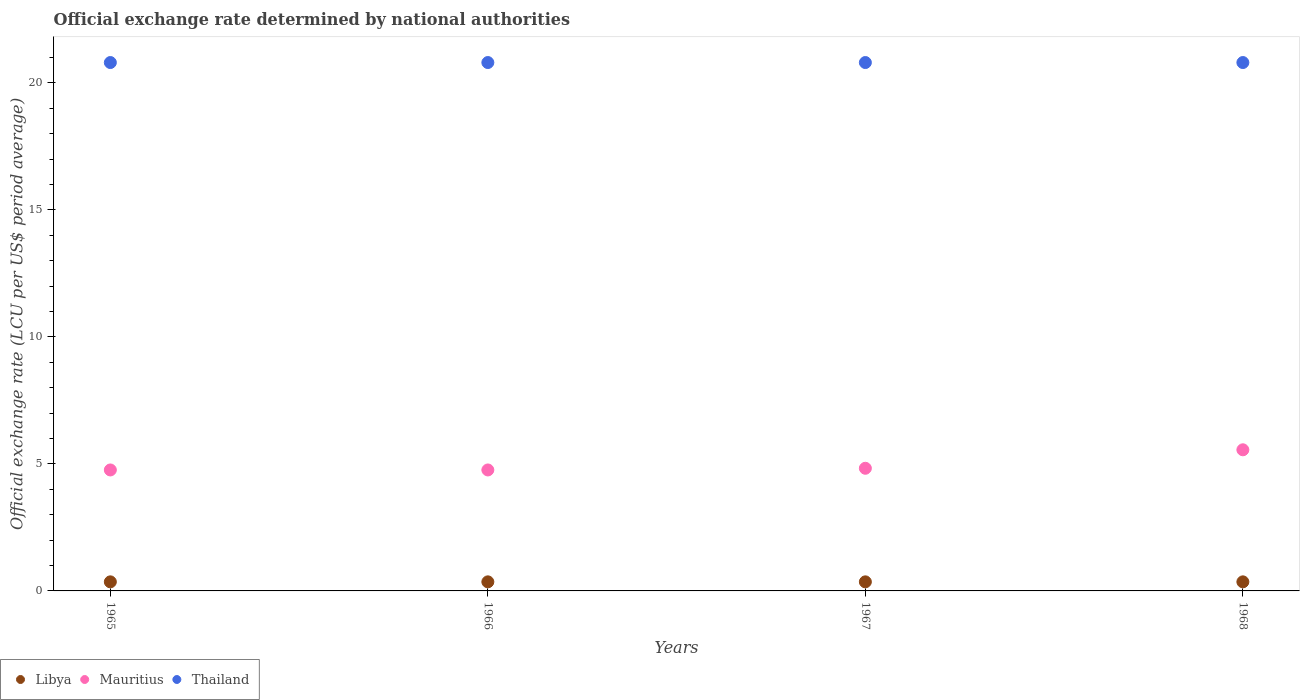Is the number of dotlines equal to the number of legend labels?
Your answer should be compact. Yes. What is the official exchange rate in Thailand in 1967?
Make the answer very short. 20.8. Across all years, what is the maximum official exchange rate in Mauritius?
Ensure brevity in your answer.  5.56. Across all years, what is the minimum official exchange rate in Libya?
Your answer should be very brief. 0.36. In which year was the official exchange rate in Libya maximum?
Offer a terse response. 1965. In which year was the official exchange rate in Mauritius minimum?
Your response must be concise. 1965. What is the total official exchange rate in Thailand in the graph?
Provide a short and direct response. 83.2. What is the difference between the official exchange rate in Mauritius in 1967 and that in 1968?
Offer a very short reply. -0.73. What is the difference between the official exchange rate in Mauritius in 1967 and the official exchange rate in Libya in 1965?
Your answer should be compact. 4.47. What is the average official exchange rate in Thailand per year?
Ensure brevity in your answer.  20.8. In the year 1966, what is the difference between the official exchange rate in Libya and official exchange rate in Thailand?
Your response must be concise. -20.44. In how many years, is the official exchange rate in Thailand greater than 13 LCU?
Your answer should be very brief. 4. What is the ratio of the official exchange rate in Libya in 1965 to that in 1967?
Provide a succinct answer. 1. Is the official exchange rate in Libya in 1965 less than that in 1968?
Make the answer very short. No. Is the difference between the official exchange rate in Libya in 1966 and 1967 greater than the difference between the official exchange rate in Thailand in 1966 and 1967?
Your response must be concise. No. What is the difference between the highest and the second highest official exchange rate in Libya?
Offer a very short reply. 0. What is the difference between the highest and the lowest official exchange rate in Libya?
Make the answer very short. 0. In how many years, is the official exchange rate in Mauritius greater than the average official exchange rate in Mauritius taken over all years?
Make the answer very short. 1. Is it the case that in every year, the sum of the official exchange rate in Mauritius and official exchange rate in Thailand  is greater than the official exchange rate in Libya?
Ensure brevity in your answer.  Yes. Does the official exchange rate in Thailand monotonically increase over the years?
Offer a very short reply. No. Is the official exchange rate in Thailand strictly greater than the official exchange rate in Mauritius over the years?
Your answer should be compact. Yes. How many dotlines are there?
Your answer should be compact. 3. How many years are there in the graph?
Provide a short and direct response. 4. Are the values on the major ticks of Y-axis written in scientific E-notation?
Your answer should be compact. No. Does the graph contain grids?
Provide a succinct answer. No. How many legend labels are there?
Your answer should be compact. 3. How are the legend labels stacked?
Your answer should be very brief. Horizontal. What is the title of the graph?
Make the answer very short. Official exchange rate determined by national authorities. What is the label or title of the Y-axis?
Your answer should be very brief. Official exchange rate (LCU per US$ period average). What is the Official exchange rate (LCU per US$ period average) of Libya in 1965?
Offer a very short reply. 0.36. What is the Official exchange rate (LCU per US$ period average) of Mauritius in 1965?
Provide a succinct answer. 4.76. What is the Official exchange rate (LCU per US$ period average) in Thailand in 1965?
Provide a succinct answer. 20.8. What is the Official exchange rate (LCU per US$ period average) of Libya in 1966?
Make the answer very short. 0.36. What is the Official exchange rate (LCU per US$ period average) of Mauritius in 1966?
Ensure brevity in your answer.  4.76. What is the Official exchange rate (LCU per US$ period average) in Thailand in 1966?
Provide a short and direct response. 20.8. What is the Official exchange rate (LCU per US$ period average) in Libya in 1967?
Provide a succinct answer. 0.36. What is the Official exchange rate (LCU per US$ period average) of Mauritius in 1967?
Provide a short and direct response. 4.83. What is the Official exchange rate (LCU per US$ period average) of Thailand in 1967?
Keep it short and to the point. 20.8. What is the Official exchange rate (LCU per US$ period average) in Libya in 1968?
Provide a short and direct response. 0.36. What is the Official exchange rate (LCU per US$ period average) of Mauritius in 1968?
Provide a succinct answer. 5.56. What is the Official exchange rate (LCU per US$ period average) of Thailand in 1968?
Your response must be concise. 20.8. Across all years, what is the maximum Official exchange rate (LCU per US$ period average) of Libya?
Your answer should be compact. 0.36. Across all years, what is the maximum Official exchange rate (LCU per US$ period average) of Mauritius?
Your answer should be very brief. 5.56. Across all years, what is the maximum Official exchange rate (LCU per US$ period average) of Thailand?
Your answer should be compact. 20.8. Across all years, what is the minimum Official exchange rate (LCU per US$ period average) of Libya?
Provide a short and direct response. 0.36. Across all years, what is the minimum Official exchange rate (LCU per US$ period average) in Mauritius?
Provide a succinct answer. 4.76. Across all years, what is the minimum Official exchange rate (LCU per US$ period average) in Thailand?
Give a very brief answer. 20.8. What is the total Official exchange rate (LCU per US$ period average) in Libya in the graph?
Offer a terse response. 1.43. What is the total Official exchange rate (LCU per US$ period average) of Mauritius in the graph?
Provide a succinct answer. 19.91. What is the total Official exchange rate (LCU per US$ period average) of Thailand in the graph?
Keep it short and to the point. 83.2. What is the difference between the Official exchange rate (LCU per US$ period average) in Libya in 1965 and that in 1966?
Give a very brief answer. 0. What is the difference between the Official exchange rate (LCU per US$ period average) of Libya in 1965 and that in 1967?
Provide a succinct answer. 0. What is the difference between the Official exchange rate (LCU per US$ period average) of Mauritius in 1965 and that in 1967?
Your answer should be compact. -0.07. What is the difference between the Official exchange rate (LCU per US$ period average) in Thailand in 1965 and that in 1967?
Ensure brevity in your answer.  0. What is the difference between the Official exchange rate (LCU per US$ period average) of Mauritius in 1965 and that in 1968?
Ensure brevity in your answer.  -0.79. What is the difference between the Official exchange rate (LCU per US$ period average) in Thailand in 1965 and that in 1968?
Offer a very short reply. 0. What is the difference between the Official exchange rate (LCU per US$ period average) in Libya in 1966 and that in 1967?
Your answer should be compact. 0. What is the difference between the Official exchange rate (LCU per US$ period average) in Mauritius in 1966 and that in 1967?
Provide a short and direct response. -0.07. What is the difference between the Official exchange rate (LCU per US$ period average) of Libya in 1966 and that in 1968?
Your answer should be compact. 0. What is the difference between the Official exchange rate (LCU per US$ period average) of Mauritius in 1966 and that in 1968?
Ensure brevity in your answer.  -0.79. What is the difference between the Official exchange rate (LCU per US$ period average) of Libya in 1967 and that in 1968?
Your answer should be compact. 0. What is the difference between the Official exchange rate (LCU per US$ period average) in Mauritius in 1967 and that in 1968?
Provide a succinct answer. -0.73. What is the difference between the Official exchange rate (LCU per US$ period average) of Thailand in 1967 and that in 1968?
Your response must be concise. 0. What is the difference between the Official exchange rate (LCU per US$ period average) of Libya in 1965 and the Official exchange rate (LCU per US$ period average) of Mauritius in 1966?
Your response must be concise. -4.4. What is the difference between the Official exchange rate (LCU per US$ period average) in Libya in 1965 and the Official exchange rate (LCU per US$ period average) in Thailand in 1966?
Offer a very short reply. -20.44. What is the difference between the Official exchange rate (LCU per US$ period average) of Mauritius in 1965 and the Official exchange rate (LCU per US$ period average) of Thailand in 1966?
Give a very brief answer. -16.04. What is the difference between the Official exchange rate (LCU per US$ period average) in Libya in 1965 and the Official exchange rate (LCU per US$ period average) in Mauritius in 1967?
Your answer should be compact. -4.47. What is the difference between the Official exchange rate (LCU per US$ period average) in Libya in 1965 and the Official exchange rate (LCU per US$ period average) in Thailand in 1967?
Make the answer very short. -20.44. What is the difference between the Official exchange rate (LCU per US$ period average) in Mauritius in 1965 and the Official exchange rate (LCU per US$ period average) in Thailand in 1967?
Offer a terse response. -16.04. What is the difference between the Official exchange rate (LCU per US$ period average) in Libya in 1965 and the Official exchange rate (LCU per US$ period average) in Mauritius in 1968?
Provide a succinct answer. -5.2. What is the difference between the Official exchange rate (LCU per US$ period average) in Libya in 1965 and the Official exchange rate (LCU per US$ period average) in Thailand in 1968?
Offer a very short reply. -20.44. What is the difference between the Official exchange rate (LCU per US$ period average) of Mauritius in 1965 and the Official exchange rate (LCU per US$ period average) of Thailand in 1968?
Give a very brief answer. -16.04. What is the difference between the Official exchange rate (LCU per US$ period average) of Libya in 1966 and the Official exchange rate (LCU per US$ period average) of Mauritius in 1967?
Offer a very short reply. -4.47. What is the difference between the Official exchange rate (LCU per US$ period average) of Libya in 1966 and the Official exchange rate (LCU per US$ period average) of Thailand in 1967?
Offer a very short reply. -20.44. What is the difference between the Official exchange rate (LCU per US$ period average) in Mauritius in 1966 and the Official exchange rate (LCU per US$ period average) in Thailand in 1967?
Offer a terse response. -16.04. What is the difference between the Official exchange rate (LCU per US$ period average) in Libya in 1966 and the Official exchange rate (LCU per US$ period average) in Mauritius in 1968?
Offer a very short reply. -5.2. What is the difference between the Official exchange rate (LCU per US$ period average) in Libya in 1966 and the Official exchange rate (LCU per US$ period average) in Thailand in 1968?
Give a very brief answer. -20.44. What is the difference between the Official exchange rate (LCU per US$ period average) in Mauritius in 1966 and the Official exchange rate (LCU per US$ period average) in Thailand in 1968?
Give a very brief answer. -16.04. What is the difference between the Official exchange rate (LCU per US$ period average) in Libya in 1967 and the Official exchange rate (LCU per US$ period average) in Mauritius in 1968?
Make the answer very short. -5.2. What is the difference between the Official exchange rate (LCU per US$ period average) of Libya in 1967 and the Official exchange rate (LCU per US$ period average) of Thailand in 1968?
Make the answer very short. -20.44. What is the difference between the Official exchange rate (LCU per US$ period average) in Mauritius in 1967 and the Official exchange rate (LCU per US$ period average) in Thailand in 1968?
Provide a short and direct response. -15.97. What is the average Official exchange rate (LCU per US$ period average) of Libya per year?
Your answer should be compact. 0.36. What is the average Official exchange rate (LCU per US$ period average) in Mauritius per year?
Offer a terse response. 4.98. What is the average Official exchange rate (LCU per US$ period average) of Thailand per year?
Ensure brevity in your answer.  20.8. In the year 1965, what is the difference between the Official exchange rate (LCU per US$ period average) in Libya and Official exchange rate (LCU per US$ period average) in Mauritius?
Make the answer very short. -4.4. In the year 1965, what is the difference between the Official exchange rate (LCU per US$ period average) of Libya and Official exchange rate (LCU per US$ period average) of Thailand?
Keep it short and to the point. -20.44. In the year 1965, what is the difference between the Official exchange rate (LCU per US$ period average) of Mauritius and Official exchange rate (LCU per US$ period average) of Thailand?
Make the answer very short. -16.04. In the year 1966, what is the difference between the Official exchange rate (LCU per US$ period average) in Libya and Official exchange rate (LCU per US$ period average) in Mauritius?
Your answer should be compact. -4.4. In the year 1966, what is the difference between the Official exchange rate (LCU per US$ period average) of Libya and Official exchange rate (LCU per US$ period average) of Thailand?
Ensure brevity in your answer.  -20.44. In the year 1966, what is the difference between the Official exchange rate (LCU per US$ period average) of Mauritius and Official exchange rate (LCU per US$ period average) of Thailand?
Your response must be concise. -16.04. In the year 1967, what is the difference between the Official exchange rate (LCU per US$ period average) of Libya and Official exchange rate (LCU per US$ period average) of Mauritius?
Make the answer very short. -4.47. In the year 1967, what is the difference between the Official exchange rate (LCU per US$ period average) in Libya and Official exchange rate (LCU per US$ period average) in Thailand?
Offer a terse response. -20.44. In the year 1967, what is the difference between the Official exchange rate (LCU per US$ period average) in Mauritius and Official exchange rate (LCU per US$ period average) in Thailand?
Your answer should be compact. -15.97. In the year 1968, what is the difference between the Official exchange rate (LCU per US$ period average) in Libya and Official exchange rate (LCU per US$ period average) in Mauritius?
Ensure brevity in your answer.  -5.2. In the year 1968, what is the difference between the Official exchange rate (LCU per US$ period average) of Libya and Official exchange rate (LCU per US$ period average) of Thailand?
Give a very brief answer. -20.44. In the year 1968, what is the difference between the Official exchange rate (LCU per US$ period average) of Mauritius and Official exchange rate (LCU per US$ period average) of Thailand?
Make the answer very short. -15.24. What is the ratio of the Official exchange rate (LCU per US$ period average) of Libya in 1965 to that in 1966?
Your response must be concise. 1. What is the ratio of the Official exchange rate (LCU per US$ period average) in Libya in 1965 to that in 1967?
Offer a terse response. 1. What is the ratio of the Official exchange rate (LCU per US$ period average) of Mauritius in 1965 to that in 1967?
Your answer should be compact. 0.99. What is the ratio of the Official exchange rate (LCU per US$ period average) in Libya in 1965 to that in 1968?
Ensure brevity in your answer.  1. What is the ratio of the Official exchange rate (LCU per US$ period average) in Mauritius in 1965 to that in 1968?
Your answer should be very brief. 0.86. What is the ratio of the Official exchange rate (LCU per US$ period average) in Thailand in 1965 to that in 1968?
Offer a very short reply. 1. What is the ratio of the Official exchange rate (LCU per US$ period average) in Libya in 1966 to that in 1967?
Make the answer very short. 1. What is the ratio of the Official exchange rate (LCU per US$ period average) in Mauritius in 1966 to that in 1967?
Give a very brief answer. 0.99. What is the ratio of the Official exchange rate (LCU per US$ period average) in Thailand in 1966 to that in 1967?
Your answer should be very brief. 1. What is the ratio of the Official exchange rate (LCU per US$ period average) in Libya in 1966 to that in 1968?
Provide a short and direct response. 1. What is the ratio of the Official exchange rate (LCU per US$ period average) in Mauritius in 1966 to that in 1968?
Provide a short and direct response. 0.86. What is the ratio of the Official exchange rate (LCU per US$ period average) of Mauritius in 1967 to that in 1968?
Offer a very short reply. 0.87. What is the ratio of the Official exchange rate (LCU per US$ period average) of Thailand in 1967 to that in 1968?
Provide a short and direct response. 1. What is the difference between the highest and the second highest Official exchange rate (LCU per US$ period average) in Mauritius?
Offer a very short reply. 0.73. What is the difference between the highest and the second highest Official exchange rate (LCU per US$ period average) of Thailand?
Keep it short and to the point. 0. What is the difference between the highest and the lowest Official exchange rate (LCU per US$ period average) in Libya?
Your answer should be very brief. 0. What is the difference between the highest and the lowest Official exchange rate (LCU per US$ period average) in Mauritius?
Ensure brevity in your answer.  0.79. What is the difference between the highest and the lowest Official exchange rate (LCU per US$ period average) in Thailand?
Keep it short and to the point. 0. 